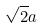Convert formula to latex. <formula><loc_0><loc_0><loc_500><loc_500>\sqrt { 2 } a</formula> 